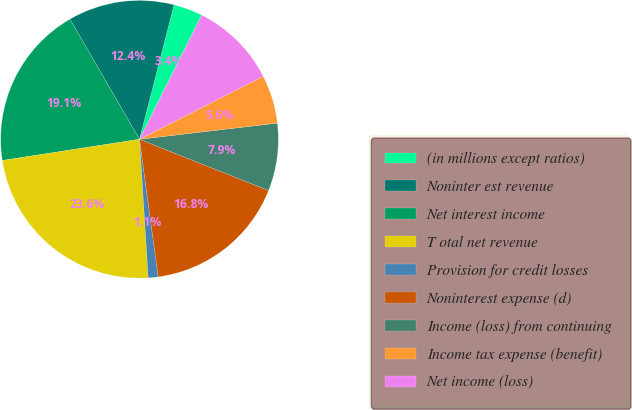<chart> <loc_0><loc_0><loc_500><loc_500><pie_chart><fcel>(in millions except ratios)<fcel>Noninter est revenue<fcel>Net interest income<fcel>T otal net revenue<fcel>Provision for credit losses<fcel>Noninterest expense (d)<fcel>Income (loss) from continuing<fcel>Income tax expense (benefit)<fcel>Net income (loss)<nl><fcel>3.39%<fcel>12.36%<fcel>19.08%<fcel>23.56%<fcel>1.15%<fcel>16.84%<fcel>7.87%<fcel>5.63%<fcel>10.12%<nl></chart> 